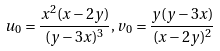Convert formula to latex. <formula><loc_0><loc_0><loc_500><loc_500>u _ { 0 } = \frac { x ^ { 2 } ( x - 2 y ) } { ( y - 3 x ) ^ { 3 } } , v _ { 0 } = \frac { y ( y - 3 x ) } { ( x - 2 y ) ^ { 2 } }</formula> 